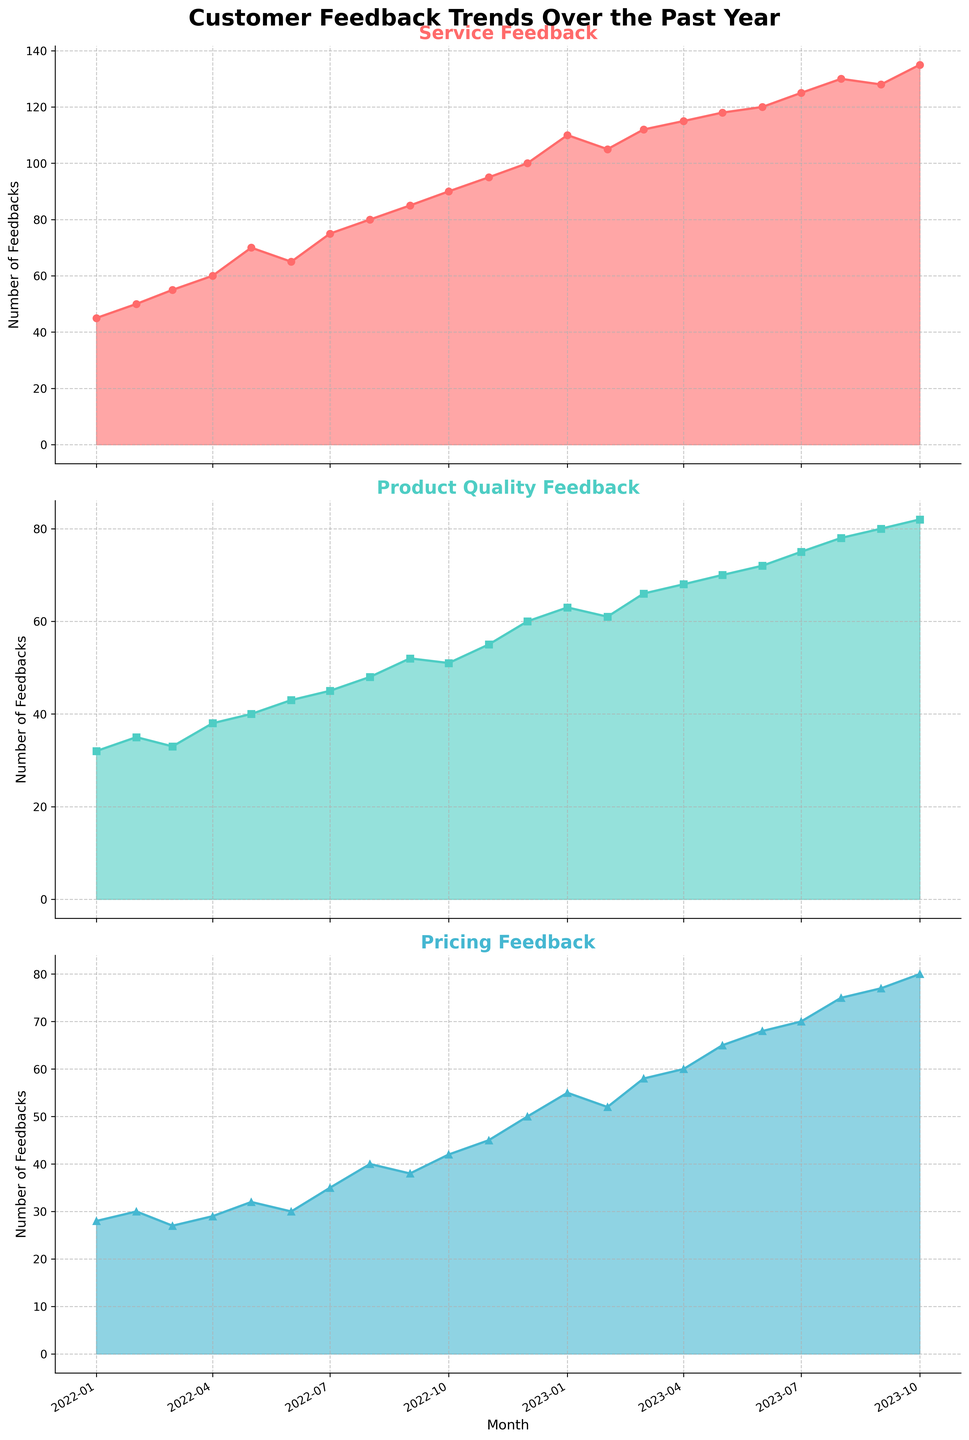What is the title of the figure? The title of the figure is usually found at the top. In this case, it's centered and bold.
Answer: Customer Feedback Trends Over the Past Year How does the number of Service Feedbacks change over the year? Observe the Service Feedback subplot. From January 2022 to October 2023, the feedback steadily increases, shown by the rising line and filled area under it.
Answer: It steadily increases Which type of feedback has the most consistent increase over the year? Compare the trends in all three subplots. Service Feedback shows a consistent linear increase, unlike the fluctuations in Product Quality Feedback and Pricing Feedback.
Answer: Service Feedback In which month did Pricing Feedback peak in the past year? Look at the Pricing Feedback subplot and find the highest point on the plot. The peak occurs where the line reaches its maximum value.
Answer: October 2023 What was the Service Feedback value in June 2023? Track the Service Feedback plot to June 2023 and note the value associated with this point.
Answer: 120 Did Product Quality Feedback ever surpass 80? Check the Product Quality Feedback subplot. The highest value is around October 2023 but it does not surpass 80; it peaks at 80.
Answer: No Compare the number of Service Feedbacks and Product Quality Feedbacks in December 2022. Which is higher and by how much? Find the data points for December 2022 in both subplots. Service Feedback has 100, and Product Quality Feedback has 60. Subtract the latter from the former.
Answer: Service Feedback is higher by 40 What's the average number of Pricing Feedbacks over the last three months (August 2023 to October 2023)? Sum the Pricing Feedback values for August, September, and October 2023 (75, 77, and 80) and divide by 3 to get the average.
Answer: (75 + 77 + 80) / 3 = 77.33 What is the overall trend for Product Quality Feedback from January 2022 to October 2023? Follow the Product Quality Feedback curve from the beginning to the end. There's an overall upward trend despite some minor fluctuations.
Answer: Upward trend How much did the Service Feedback change from January 2022 to October 2023? Subtract the value of Service Feedback in January 2022 (45) from that in October 2023 (135).
Answer: 90 